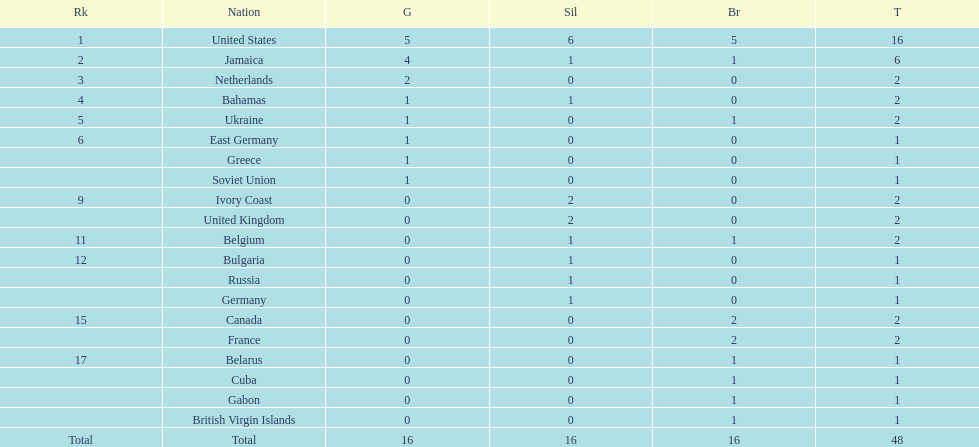How many nations won no gold medals? 12. 